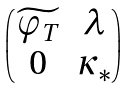Convert formula to latex. <formula><loc_0><loc_0><loc_500><loc_500>\begin{pmatrix} \widetilde { \varphi _ { T } } & \lambda \\ 0 & \kappa _ { * } \end{pmatrix}</formula> 